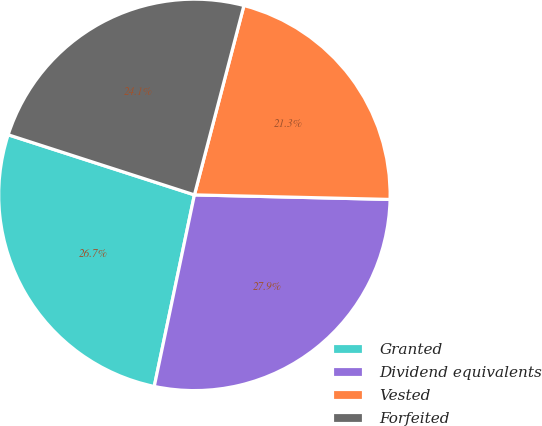<chart> <loc_0><loc_0><loc_500><loc_500><pie_chart><fcel>Granted<fcel>Dividend equivalents<fcel>Vested<fcel>Forfeited<nl><fcel>26.68%<fcel>27.92%<fcel>21.3%<fcel>24.1%<nl></chart> 